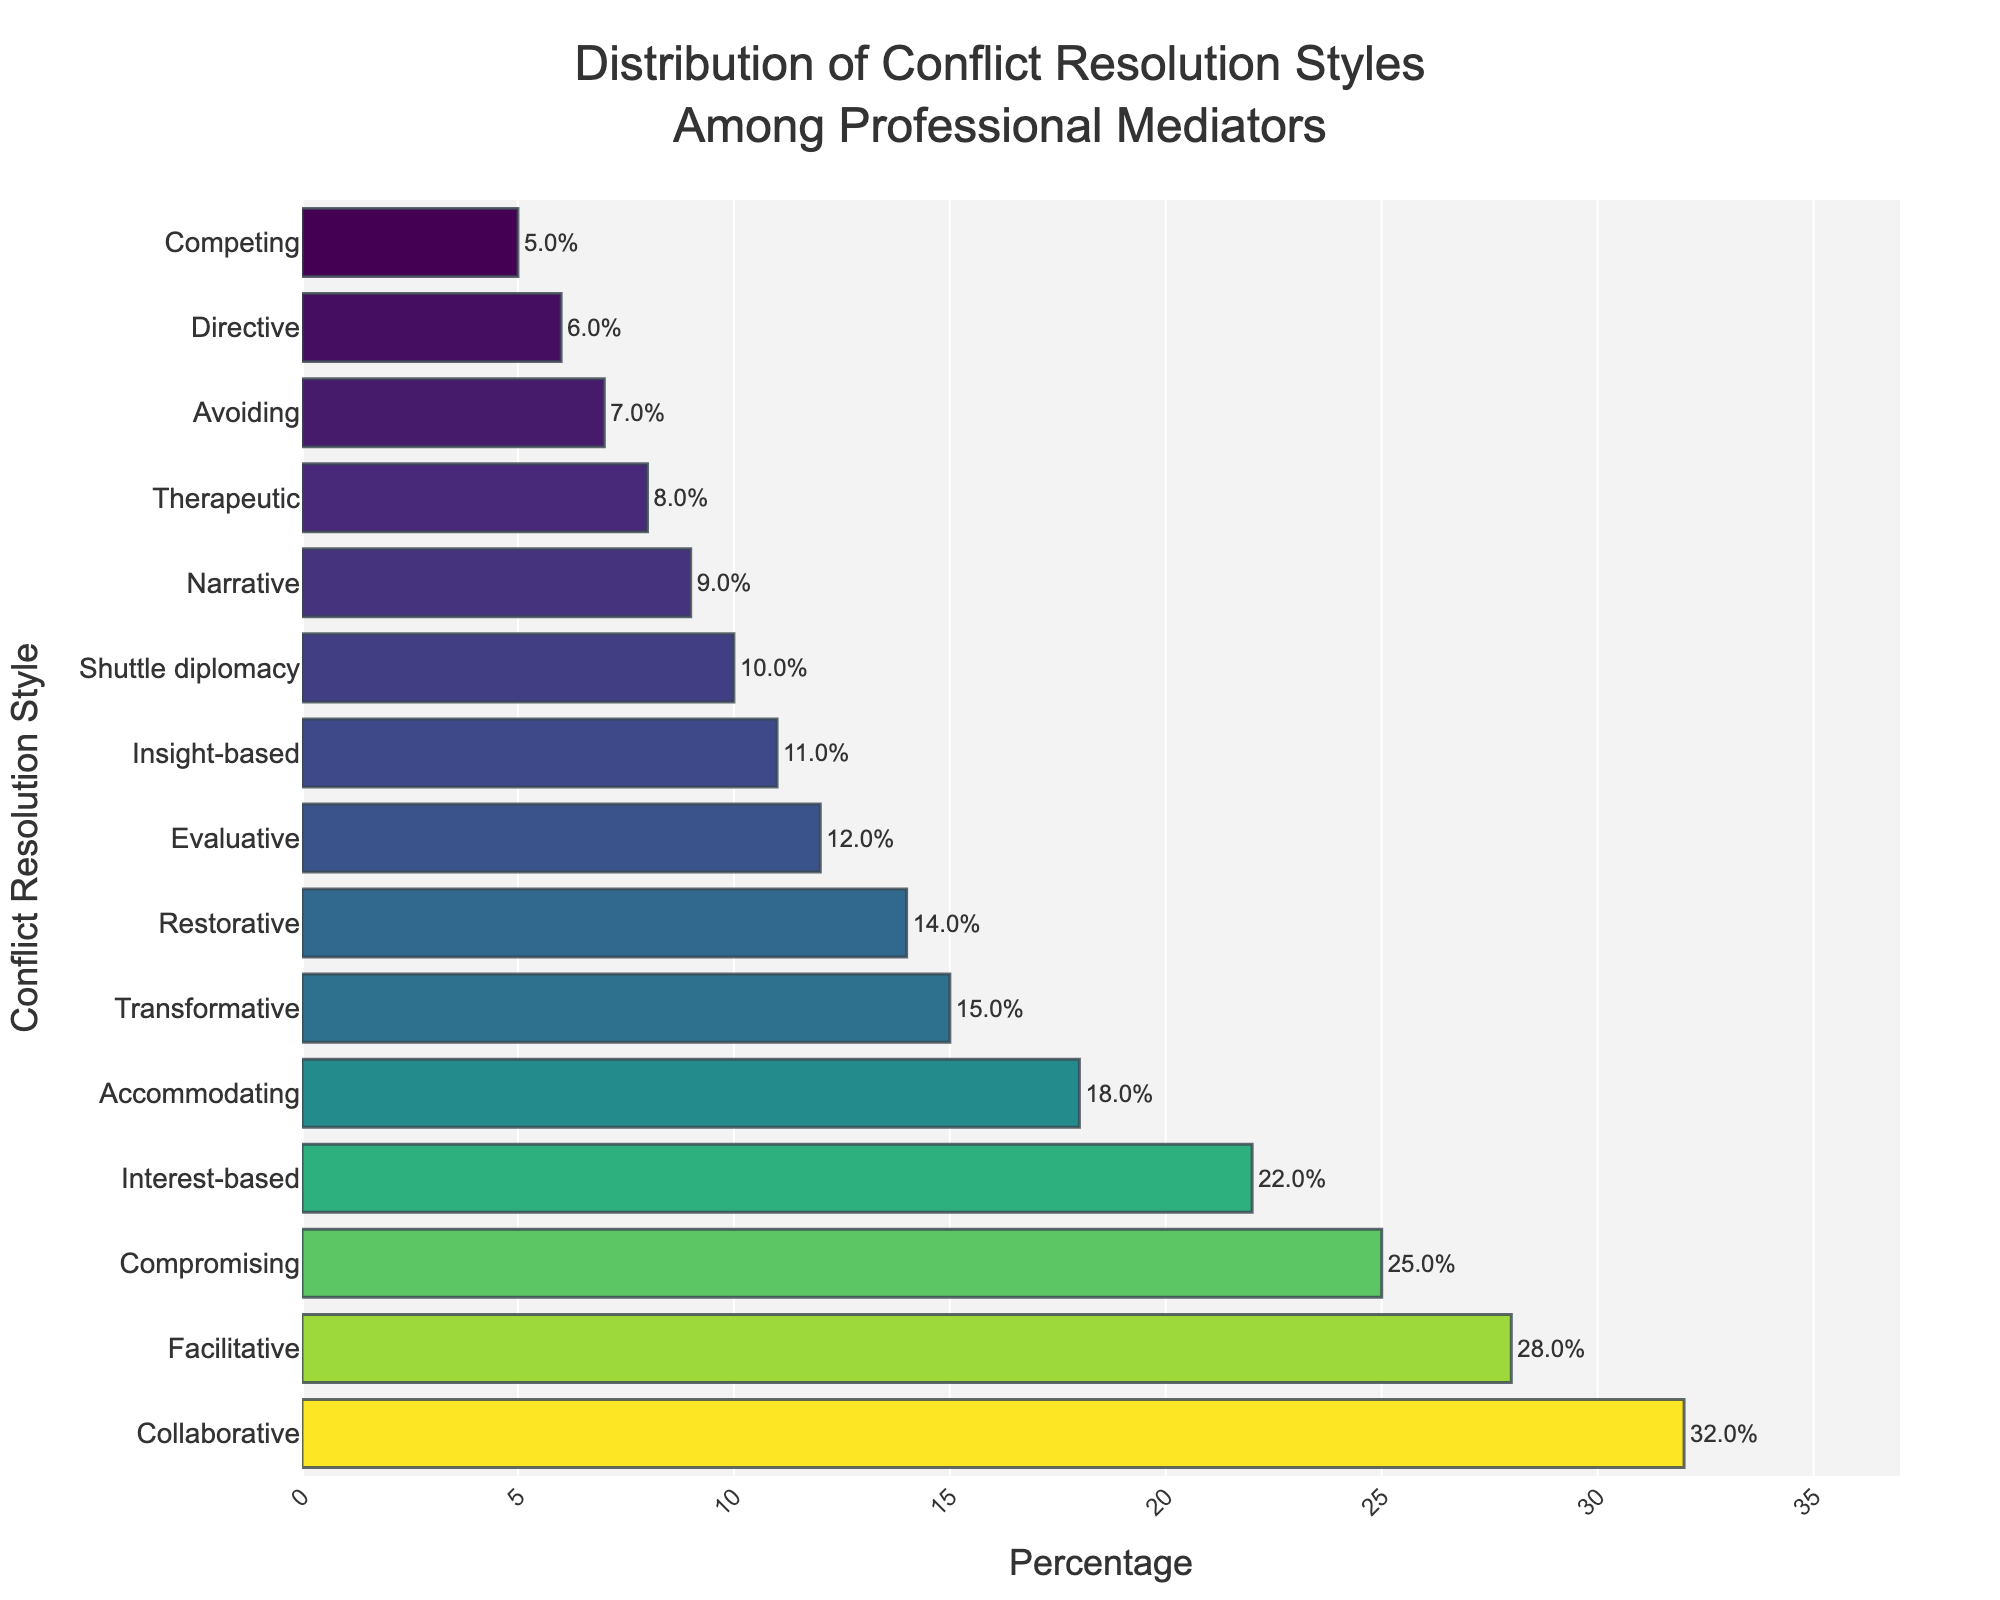What is the most common conflict resolution style among professional mediators? To determine the most common conflict resolution style, look for the bar with the greatest length or highest value in the chart. In this case, the "Collaborative" style has the highest percentage value.
Answer: Collaborative Which conflict resolution style has a higher percentage, Accommodating or Compromising? To answer this, compare the percentage values of the "Accommodating" and "Compromising" styles in the figure. Accommodating has 18%, and Compromising has 25%.
Answer: Compromising What is the percentage difference between the Facilitative and Transformative conflict resolution styles? To calculate the percentage difference, subtract the percentage of the Transformative style from that of the Facilitative style: 28% - 15% = 13%.
Answer: 13% Among Accommodating, Avoiding, and Competing, which style has the lowest percentage? Compare the percentages of each style: Accommodating (18%), Avoiding (7%), and Competing (5%). The one with the smallest percentage is the answer.
Answer: Competing What is the sum of the percentages for the top three most common conflict resolution styles? Identify the top three percentages: Collaborative (32%), Facilitative (28%), and Compromising (25%). Sum these values: 32% + 28% + 25% = 85%.
Answer: 85% What is the average percentage of the Shuttle diplomacy, Insight-based, and Therapeutic styles? Find the percentages for Shuttle diplomacy (10%), Insight-based (11%), and Therapeutic (8%). Sum these values: 10% + 11% + 8% = 29%, then divide by three: 29% / 3 ≈ 9.67%.
Answer: 9.67% Which conflict resolution styles have a percentage greater than 20%? Identify the styles with percentages more than 20%: Collaborative (32%), Facilitative (28%), Compromising (25%), and Interest-based (22%).
Answer: Collaborative, Facilitative, Compromising, Interest-based How many conflict resolution styles have a percentage less than 10%? Count the styles with less than 10%: Avoiding (7%), Competing (5%), Narrative (9%), Therapeutic (8%), Directive (6%), and Shuttle diplomacy (10%). This gives six styles.
Answer: 6 Do more mediators use the Evaluative style or the Transformative style? Compare the percentages of the Evaluative (12%) and Transformative (15%) styles. Transformative has a higher percentage.
Answer: Transformative What is the median percentage of all conflict resolution styles? To find the median, list the percentages in ascending order and find the middle value. The sorted list is 5, 6, 7, 8, 9, 10, 11, 12, 14, 15, 18, 22, 25, 28, 32. The median is the middle value, the eighth entry: 12%.
Answer: 12% 